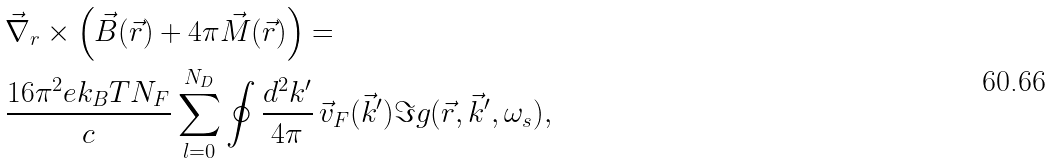Convert formula to latex. <formula><loc_0><loc_0><loc_500><loc_500>& \vec { \nabla } _ { r } \times \left ( \vec { B } ( \vec { r } ) + 4 \pi \vec { M } ( \vec { r } ) \right ) = \\ & \frac { 1 6 \pi ^ { 2 } e k _ { B } T N _ { F } } { c } \sum _ { l = 0 } ^ { N _ { D } } \oint \frac { d ^ { 2 } k ^ { \prime } } { 4 \pi } \, \vec { v } _ { F } ( \vec { k } ^ { \prime } ) \Im g ( \vec { r } , \vec { k } ^ { \prime } , \omega _ { s } ) ,</formula> 